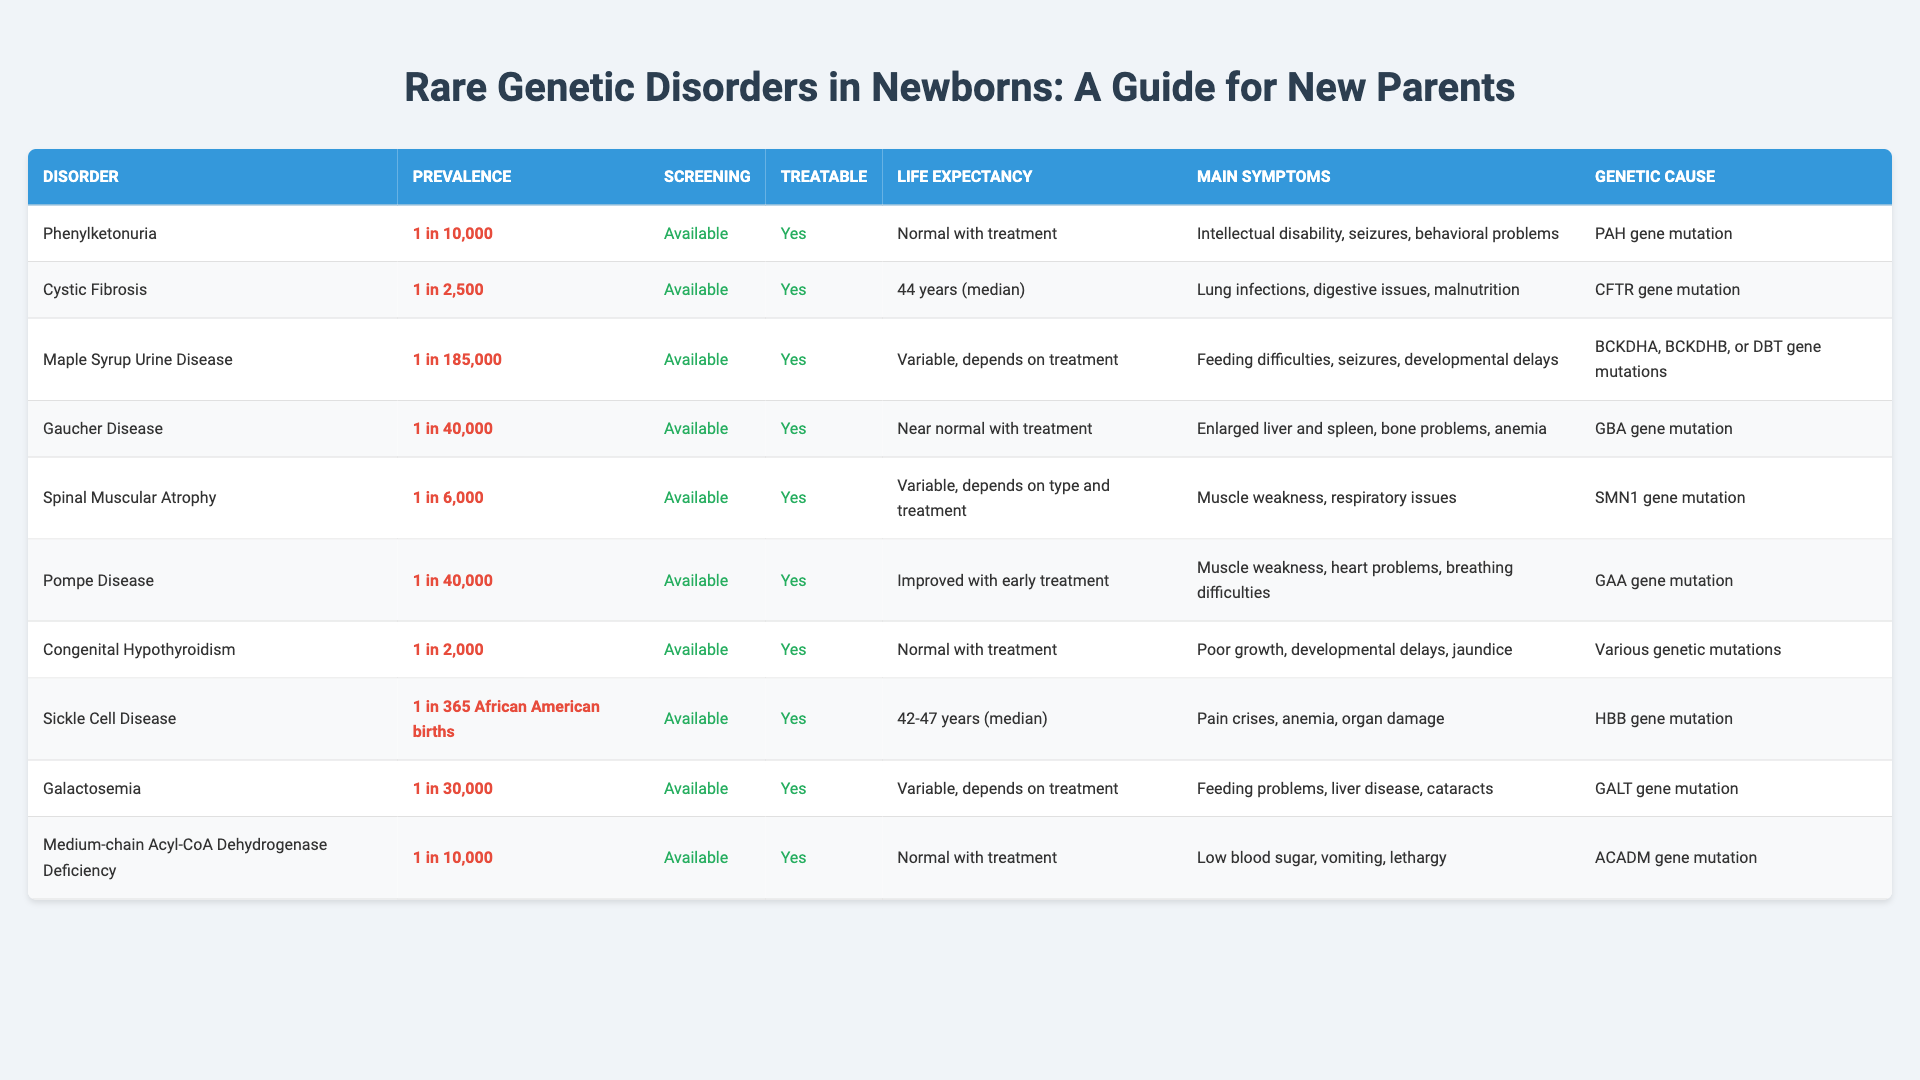What is the prevalence rate of Cystic Fibrosis? The table lists the prevalence rate for Cystic Fibrosis under the "Prevalence" column, which shows "1 in 2,500".
Answer: 1 in 2,500 Which disorder has the highest prevalence rate? To find this, we can compare the prevalence rates listed for each disorder. Cystic Fibrosis has a prevalence of "1 in 2,500," which is higher than other disorders shown.
Answer: Cystic Fibrosis Is screening available for Maple Syrup Urine Disease? The table indicates whether screening is available in the "Screening" column for each disorder. For Maple Syrup Urine Disease, it specifies "Available."
Answer: Yes What are the main symptoms of Congenital Hypothyroidism? To answer this, we can look at the "Main Symptoms" column for Congenital Hypothyroidism, which lists "Poor growth, developmental delays, jaundice."
Answer: Poor growth, developmental delays, jaundice How many disorders listed have a normal life expectancy with treatment? We can check the "Life Expectancy" column to find which disorders state "Normal with treatment." The disorders are Phenylketonuria, Congenital Hypothyroidism, and Medium-chain Acyl-CoA Dehydrogenase Deficiency, totaling three.
Answer: 3 Which disorder has a genetic cause involving the CFTR gene? By examining the "Genetic Cause" column in the table, we find that Cystic Fibrosis is linked to the CFTR gene mutation.
Answer: Cystic Fibrosis If a child is diagnosed with Sickle Cell Disease, what is the median life expectancy? The table contains a specific entry under "Life Expectancy" for Sickle Cell Disease, which states "42-47 years (median)."
Answer: 42-47 years (median) What is the difference in prevalence rate between Sickle Cell Disease and Cystic Fibrosis? Sickle Cell Disease has a prevalence of "1 in 365," while Cystic Fibrosis has "1 in 2,500." To find the difference, we convert these values: "1 in 2,500" equals approximately 0.0004 and "1 in 365" equals approximately 0.00274, thus the difference is quite significant.
Answer: Significant difference Is treatment possible for all disorders listed? The table indicates in the "Treatable" column for all disorders, and they all show "Yes." Hence, it confirms that treatment is possible for each case.
Answer: Yes Among the disorders, which has the lowest prevalence rate? Referring to the prevalence rates listed, Maple Syrup Urine Disease shows the lowest prevalence at "1 in 185,000," as tabled.
Answer: Maple Syrup Urine Disease 